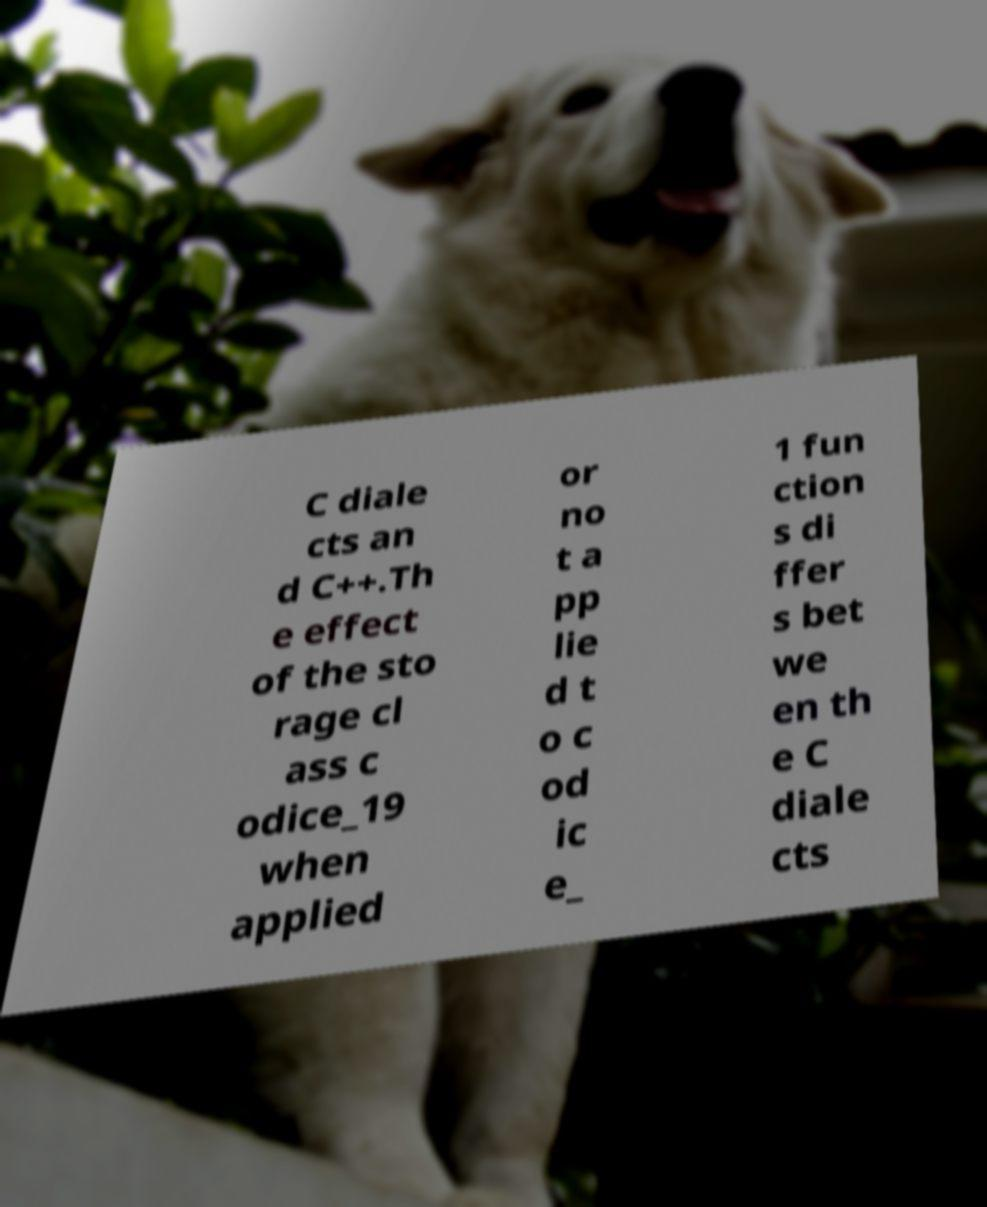Can you accurately transcribe the text from the provided image for me? C diale cts an d C++.Th e effect of the sto rage cl ass c odice_19 when applied or no t a pp lie d t o c od ic e_ 1 fun ction s di ffer s bet we en th e C diale cts 